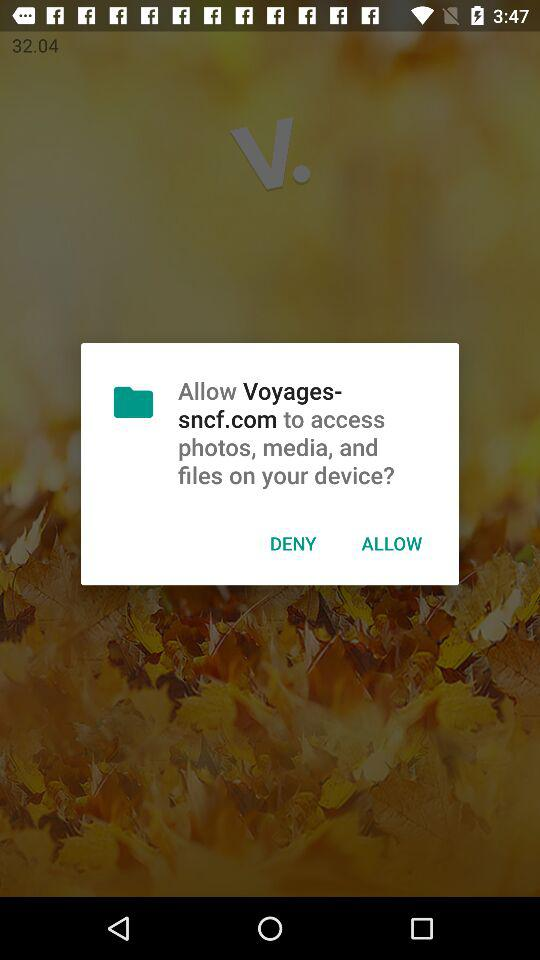What is "Voyages-sncf.com" asking to access? "Voyages-snfc.com" is asking to access photos, media, and files on your device. 